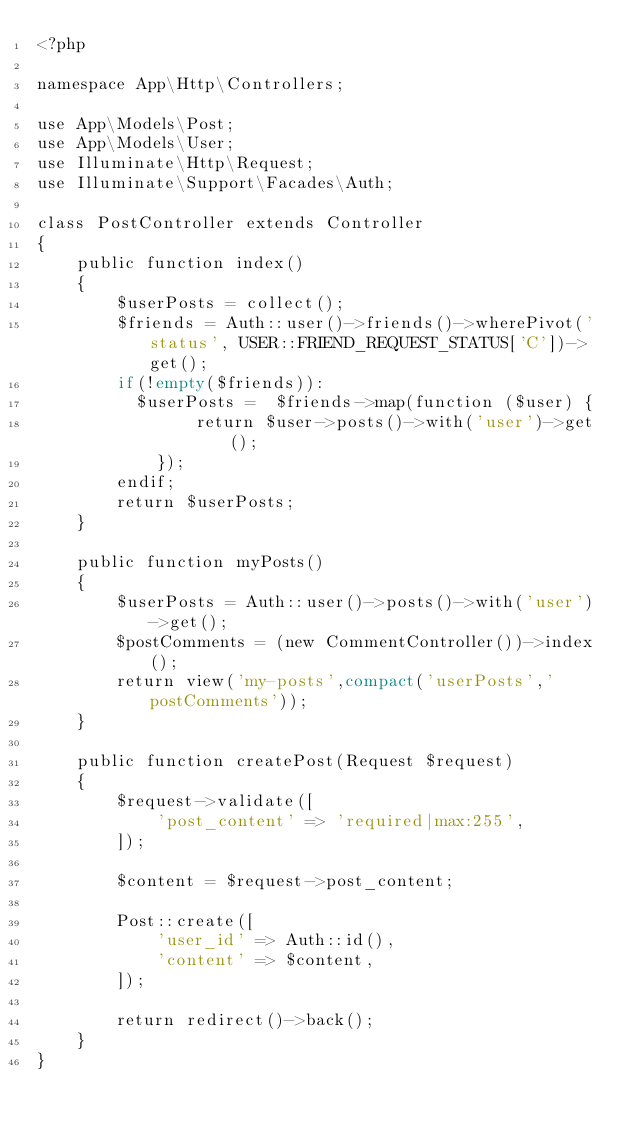<code> <loc_0><loc_0><loc_500><loc_500><_PHP_><?php

namespace App\Http\Controllers;

use App\Models\Post;
use App\Models\User;
use Illuminate\Http\Request;
use Illuminate\Support\Facades\Auth;

class PostController extends Controller
{
    public function index()
    {
        $userPosts = collect();
        $friends = Auth::user()->friends()->wherePivot('status', USER::FRIEND_REQUEST_STATUS['C'])->get();
        if(!empty($friends)):
          $userPosts =  $friends->map(function ($user) {
                return $user->posts()->with('user')->get();
            });
        endif;
        return $userPosts;
    }

    public function myPosts()
    {
        $userPosts = Auth::user()->posts()->with('user')->get();
        $postComments = (new CommentController())->index();
        return view('my-posts',compact('userPosts','postComments'));
    }

    public function createPost(Request $request)
    {
        $request->validate([
            'post_content' => 'required|max:255',
        ]);

        $content = $request->post_content;

        Post::create([
            'user_id' => Auth::id(),
            'content' => $content,
        ]);

        return redirect()->back();
    }
}
</code> 